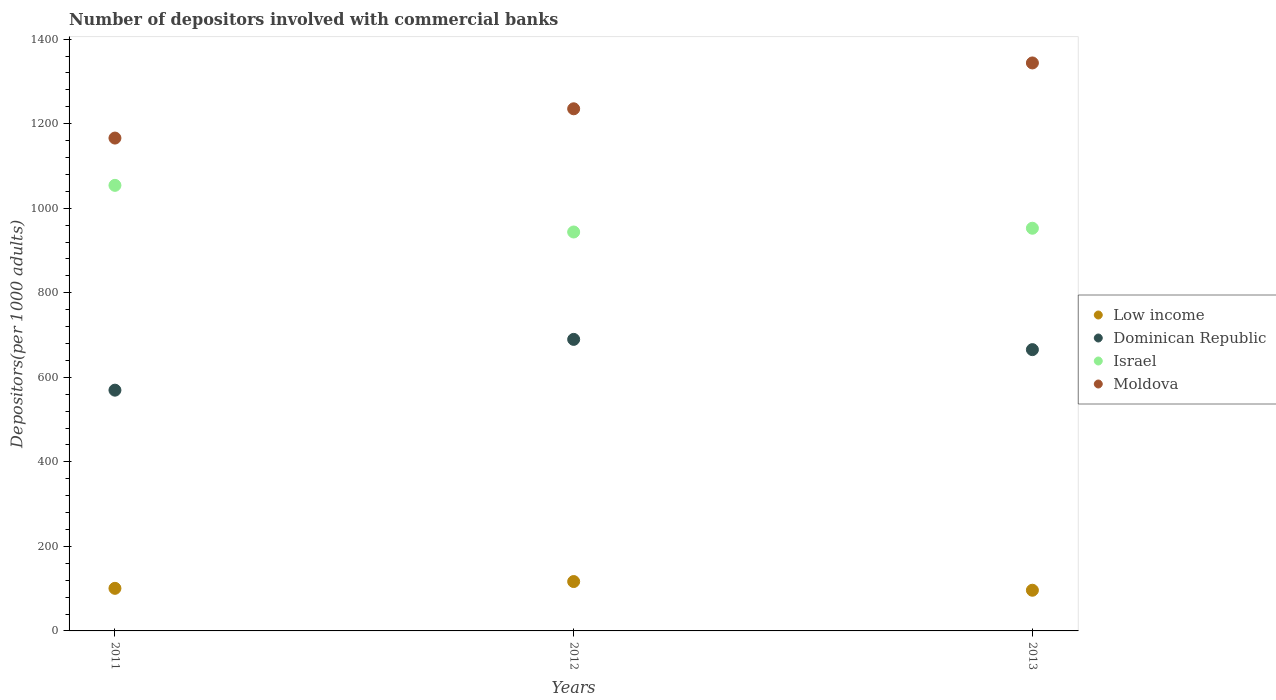How many different coloured dotlines are there?
Ensure brevity in your answer.  4. Is the number of dotlines equal to the number of legend labels?
Your answer should be compact. Yes. What is the number of depositors involved with commercial banks in Israel in 2013?
Your response must be concise. 952.62. Across all years, what is the maximum number of depositors involved with commercial banks in Israel?
Keep it short and to the point. 1054.06. Across all years, what is the minimum number of depositors involved with commercial banks in Dominican Republic?
Provide a succinct answer. 569.55. In which year was the number of depositors involved with commercial banks in Dominican Republic minimum?
Your response must be concise. 2011. What is the total number of depositors involved with commercial banks in Moldova in the graph?
Provide a succinct answer. 3744.77. What is the difference between the number of depositors involved with commercial banks in Dominican Republic in 2011 and that in 2013?
Make the answer very short. -95.87. What is the difference between the number of depositors involved with commercial banks in Moldova in 2013 and the number of depositors involved with commercial banks in Low income in 2012?
Provide a short and direct response. 1226.86. What is the average number of depositors involved with commercial banks in Low income per year?
Offer a terse response. 104.6. In the year 2012, what is the difference between the number of depositors involved with commercial banks in Israel and number of depositors involved with commercial banks in Moldova?
Provide a short and direct response. -291.46. What is the ratio of the number of depositors involved with commercial banks in Low income in 2012 to that in 2013?
Provide a succinct answer. 1.21. What is the difference between the highest and the second highest number of depositors involved with commercial banks in Israel?
Your response must be concise. 101.44. What is the difference between the highest and the lowest number of depositors involved with commercial banks in Low income?
Your answer should be very brief. 20.56. Is it the case that in every year, the sum of the number of depositors involved with commercial banks in Israel and number of depositors involved with commercial banks in Low income  is greater than the number of depositors involved with commercial banks in Moldova?
Offer a terse response. No. Does the number of depositors involved with commercial banks in Dominican Republic monotonically increase over the years?
Provide a short and direct response. No. How many years are there in the graph?
Ensure brevity in your answer.  3. How many legend labels are there?
Your answer should be very brief. 4. How are the legend labels stacked?
Keep it short and to the point. Vertical. What is the title of the graph?
Keep it short and to the point. Number of depositors involved with commercial banks. Does "Channel Islands" appear as one of the legend labels in the graph?
Ensure brevity in your answer.  No. What is the label or title of the Y-axis?
Make the answer very short. Depositors(per 1000 adults). What is the Depositors(per 1000 adults) in Low income in 2011?
Your response must be concise. 100.75. What is the Depositors(per 1000 adults) in Dominican Republic in 2011?
Provide a succinct answer. 569.55. What is the Depositors(per 1000 adults) of Israel in 2011?
Provide a short and direct response. 1054.06. What is the Depositors(per 1000 adults) of Moldova in 2011?
Ensure brevity in your answer.  1165.93. What is the Depositors(per 1000 adults) of Low income in 2012?
Provide a succinct answer. 116.8. What is the Depositors(per 1000 adults) in Dominican Republic in 2012?
Provide a succinct answer. 689.69. What is the Depositors(per 1000 adults) in Israel in 2012?
Provide a short and direct response. 943.72. What is the Depositors(per 1000 adults) of Moldova in 2012?
Offer a terse response. 1235.18. What is the Depositors(per 1000 adults) of Low income in 2013?
Provide a short and direct response. 96.24. What is the Depositors(per 1000 adults) in Dominican Republic in 2013?
Give a very brief answer. 665.43. What is the Depositors(per 1000 adults) of Israel in 2013?
Your answer should be compact. 952.62. What is the Depositors(per 1000 adults) in Moldova in 2013?
Your answer should be compact. 1343.66. Across all years, what is the maximum Depositors(per 1000 adults) of Low income?
Provide a short and direct response. 116.8. Across all years, what is the maximum Depositors(per 1000 adults) of Dominican Republic?
Your response must be concise. 689.69. Across all years, what is the maximum Depositors(per 1000 adults) in Israel?
Ensure brevity in your answer.  1054.06. Across all years, what is the maximum Depositors(per 1000 adults) of Moldova?
Your answer should be very brief. 1343.66. Across all years, what is the minimum Depositors(per 1000 adults) in Low income?
Provide a short and direct response. 96.24. Across all years, what is the minimum Depositors(per 1000 adults) in Dominican Republic?
Your response must be concise. 569.55. Across all years, what is the minimum Depositors(per 1000 adults) of Israel?
Provide a succinct answer. 943.72. Across all years, what is the minimum Depositors(per 1000 adults) of Moldova?
Provide a short and direct response. 1165.93. What is the total Depositors(per 1000 adults) in Low income in the graph?
Provide a short and direct response. 313.79. What is the total Depositors(per 1000 adults) of Dominican Republic in the graph?
Give a very brief answer. 1924.68. What is the total Depositors(per 1000 adults) of Israel in the graph?
Your answer should be compact. 2950.4. What is the total Depositors(per 1000 adults) of Moldova in the graph?
Provide a succinct answer. 3744.77. What is the difference between the Depositors(per 1000 adults) in Low income in 2011 and that in 2012?
Ensure brevity in your answer.  -16.05. What is the difference between the Depositors(per 1000 adults) in Dominican Republic in 2011 and that in 2012?
Offer a terse response. -120.14. What is the difference between the Depositors(per 1000 adults) in Israel in 2011 and that in 2012?
Make the answer very short. 110.33. What is the difference between the Depositors(per 1000 adults) in Moldova in 2011 and that in 2012?
Ensure brevity in your answer.  -69.25. What is the difference between the Depositors(per 1000 adults) of Low income in 2011 and that in 2013?
Your response must be concise. 4.5. What is the difference between the Depositors(per 1000 adults) of Dominican Republic in 2011 and that in 2013?
Keep it short and to the point. -95.87. What is the difference between the Depositors(per 1000 adults) in Israel in 2011 and that in 2013?
Your answer should be very brief. 101.44. What is the difference between the Depositors(per 1000 adults) in Moldova in 2011 and that in 2013?
Offer a very short reply. -177.73. What is the difference between the Depositors(per 1000 adults) of Low income in 2012 and that in 2013?
Make the answer very short. 20.56. What is the difference between the Depositors(per 1000 adults) of Dominican Republic in 2012 and that in 2013?
Make the answer very short. 24.27. What is the difference between the Depositors(per 1000 adults) of Israel in 2012 and that in 2013?
Offer a very short reply. -8.9. What is the difference between the Depositors(per 1000 adults) in Moldova in 2012 and that in 2013?
Your answer should be very brief. -108.47. What is the difference between the Depositors(per 1000 adults) of Low income in 2011 and the Depositors(per 1000 adults) of Dominican Republic in 2012?
Make the answer very short. -588.95. What is the difference between the Depositors(per 1000 adults) of Low income in 2011 and the Depositors(per 1000 adults) of Israel in 2012?
Your response must be concise. -842.98. What is the difference between the Depositors(per 1000 adults) of Low income in 2011 and the Depositors(per 1000 adults) of Moldova in 2012?
Keep it short and to the point. -1134.44. What is the difference between the Depositors(per 1000 adults) of Dominican Republic in 2011 and the Depositors(per 1000 adults) of Israel in 2012?
Ensure brevity in your answer.  -374.17. What is the difference between the Depositors(per 1000 adults) of Dominican Republic in 2011 and the Depositors(per 1000 adults) of Moldova in 2012?
Keep it short and to the point. -665.63. What is the difference between the Depositors(per 1000 adults) of Israel in 2011 and the Depositors(per 1000 adults) of Moldova in 2012?
Your response must be concise. -181.13. What is the difference between the Depositors(per 1000 adults) of Low income in 2011 and the Depositors(per 1000 adults) of Dominican Republic in 2013?
Ensure brevity in your answer.  -564.68. What is the difference between the Depositors(per 1000 adults) of Low income in 2011 and the Depositors(per 1000 adults) of Israel in 2013?
Your answer should be compact. -851.87. What is the difference between the Depositors(per 1000 adults) of Low income in 2011 and the Depositors(per 1000 adults) of Moldova in 2013?
Give a very brief answer. -1242.91. What is the difference between the Depositors(per 1000 adults) in Dominican Republic in 2011 and the Depositors(per 1000 adults) in Israel in 2013?
Offer a very short reply. -383.07. What is the difference between the Depositors(per 1000 adults) of Dominican Republic in 2011 and the Depositors(per 1000 adults) of Moldova in 2013?
Keep it short and to the point. -774.11. What is the difference between the Depositors(per 1000 adults) of Israel in 2011 and the Depositors(per 1000 adults) of Moldova in 2013?
Provide a succinct answer. -289.6. What is the difference between the Depositors(per 1000 adults) in Low income in 2012 and the Depositors(per 1000 adults) in Dominican Republic in 2013?
Keep it short and to the point. -548.63. What is the difference between the Depositors(per 1000 adults) in Low income in 2012 and the Depositors(per 1000 adults) in Israel in 2013?
Ensure brevity in your answer.  -835.82. What is the difference between the Depositors(per 1000 adults) of Low income in 2012 and the Depositors(per 1000 adults) of Moldova in 2013?
Offer a very short reply. -1226.86. What is the difference between the Depositors(per 1000 adults) of Dominican Republic in 2012 and the Depositors(per 1000 adults) of Israel in 2013?
Keep it short and to the point. -262.93. What is the difference between the Depositors(per 1000 adults) of Dominican Republic in 2012 and the Depositors(per 1000 adults) of Moldova in 2013?
Give a very brief answer. -653.96. What is the difference between the Depositors(per 1000 adults) of Israel in 2012 and the Depositors(per 1000 adults) of Moldova in 2013?
Provide a short and direct response. -399.93. What is the average Depositors(per 1000 adults) in Low income per year?
Make the answer very short. 104.6. What is the average Depositors(per 1000 adults) in Dominican Republic per year?
Offer a very short reply. 641.56. What is the average Depositors(per 1000 adults) of Israel per year?
Your answer should be compact. 983.47. What is the average Depositors(per 1000 adults) of Moldova per year?
Make the answer very short. 1248.26. In the year 2011, what is the difference between the Depositors(per 1000 adults) of Low income and Depositors(per 1000 adults) of Dominican Republic?
Your answer should be very brief. -468.81. In the year 2011, what is the difference between the Depositors(per 1000 adults) in Low income and Depositors(per 1000 adults) in Israel?
Your response must be concise. -953.31. In the year 2011, what is the difference between the Depositors(per 1000 adults) in Low income and Depositors(per 1000 adults) in Moldova?
Offer a terse response. -1065.18. In the year 2011, what is the difference between the Depositors(per 1000 adults) of Dominican Republic and Depositors(per 1000 adults) of Israel?
Provide a short and direct response. -484.5. In the year 2011, what is the difference between the Depositors(per 1000 adults) of Dominican Republic and Depositors(per 1000 adults) of Moldova?
Provide a succinct answer. -596.38. In the year 2011, what is the difference between the Depositors(per 1000 adults) in Israel and Depositors(per 1000 adults) in Moldova?
Your response must be concise. -111.87. In the year 2012, what is the difference between the Depositors(per 1000 adults) in Low income and Depositors(per 1000 adults) in Dominican Republic?
Provide a succinct answer. -572.9. In the year 2012, what is the difference between the Depositors(per 1000 adults) of Low income and Depositors(per 1000 adults) of Israel?
Your response must be concise. -826.92. In the year 2012, what is the difference between the Depositors(per 1000 adults) in Low income and Depositors(per 1000 adults) in Moldova?
Give a very brief answer. -1118.38. In the year 2012, what is the difference between the Depositors(per 1000 adults) of Dominican Republic and Depositors(per 1000 adults) of Israel?
Provide a succinct answer. -254.03. In the year 2012, what is the difference between the Depositors(per 1000 adults) in Dominican Republic and Depositors(per 1000 adults) in Moldova?
Give a very brief answer. -545.49. In the year 2012, what is the difference between the Depositors(per 1000 adults) in Israel and Depositors(per 1000 adults) in Moldova?
Your answer should be compact. -291.46. In the year 2013, what is the difference between the Depositors(per 1000 adults) in Low income and Depositors(per 1000 adults) in Dominican Republic?
Offer a very short reply. -569.18. In the year 2013, what is the difference between the Depositors(per 1000 adults) of Low income and Depositors(per 1000 adults) of Israel?
Make the answer very short. -856.38. In the year 2013, what is the difference between the Depositors(per 1000 adults) of Low income and Depositors(per 1000 adults) of Moldova?
Offer a very short reply. -1247.41. In the year 2013, what is the difference between the Depositors(per 1000 adults) of Dominican Republic and Depositors(per 1000 adults) of Israel?
Give a very brief answer. -287.19. In the year 2013, what is the difference between the Depositors(per 1000 adults) of Dominican Republic and Depositors(per 1000 adults) of Moldova?
Make the answer very short. -678.23. In the year 2013, what is the difference between the Depositors(per 1000 adults) in Israel and Depositors(per 1000 adults) in Moldova?
Your answer should be compact. -391.04. What is the ratio of the Depositors(per 1000 adults) of Low income in 2011 to that in 2012?
Your response must be concise. 0.86. What is the ratio of the Depositors(per 1000 adults) of Dominican Republic in 2011 to that in 2012?
Keep it short and to the point. 0.83. What is the ratio of the Depositors(per 1000 adults) in Israel in 2011 to that in 2012?
Keep it short and to the point. 1.12. What is the ratio of the Depositors(per 1000 adults) of Moldova in 2011 to that in 2012?
Keep it short and to the point. 0.94. What is the ratio of the Depositors(per 1000 adults) in Low income in 2011 to that in 2013?
Ensure brevity in your answer.  1.05. What is the ratio of the Depositors(per 1000 adults) in Dominican Republic in 2011 to that in 2013?
Provide a succinct answer. 0.86. What is the ratio of the Depositors(per 1000 adults) in Israel in 2011 to that in 2013?
Keep it short and to the point. 1.11. What is the ratio of the Depositors(per 1000 adults) in Moldova in 2011 to that in 2013?
Provide a short and direct response. 0.87. What is the ratio of the Depositors(per 1000 adults) of Low income in 2012 to that in 2013?
Your answer should be very brief. 1.21. What is the ratio of the Depositors(per 1000 adults) in Dominican Republic in 2012 to that in 2013?
Your answer should be compact. 1.04. What is the ratio of the Depositors(per 1000 adults) in Israel in 2012 to that in 2013?
Your answer should be very brief. 0.99. What is the ratio of the Depositors(per 1000 adults) of Moldova in 2012 to that in 2013?
Give a very brief answer. 0.92. What is the difference between the highest and the second highest Depositors(per 1000 adults) in Low income?
Your response must be concise. 16.05. What is the difference between the highest and the second highest Depositors(per 1000 adults) of Dominican Republic?
Give a very brief answer. 24.27. What is the difference between the highest and the second highest Depositors(per 1000 adults) in Israel?
Provide a succinct answer. 101.44. What is the difference between the highest and the second highest Depositors(per 1000 adults) of Moldova?
Your answer should be very brief. 108.47. What is the difference between the highest and the lowest Depositors(per 1000 adults) of Low income?
Your answer should be very brief. 20.56. What is the difference between the highest and the lowest Depositors(per 1000 adults) of Dominican Republic?
Your answer should be compact. 120.14. What is the difference between the highest and the lowest Depositors(per 1000 adults) of Israel?
Ensure brevity in your answer.  110.33. What is the difference between the highest and the lowest Depositors(per 1000 adults) in Moldova?
Offer a terse response. 177.73. 